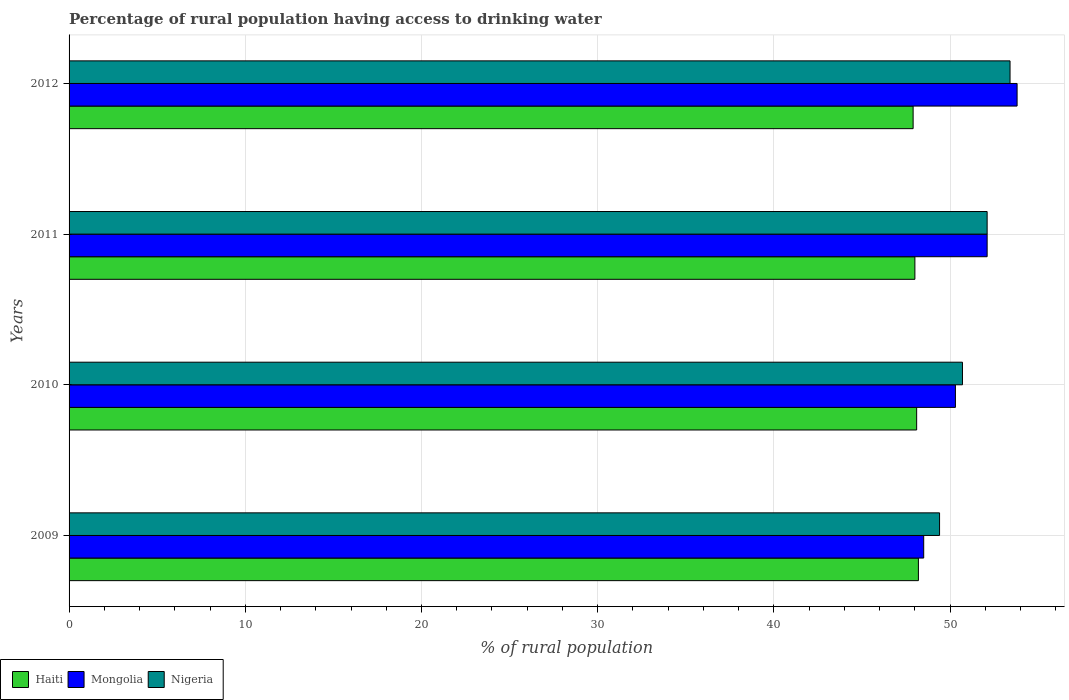Are the number of bars per tick equal to the number of legend labels?
Ensure brevity in your answer.  Yes. Are the number of bars on each tick of the Y-axis equal?
Your response must be concise. Yes. How many bars are there on the 1st tick from the top?
Make the answer very short. 3. What is the label of the 3rd group of bars from the top?
Offer a very short reply. 2010. What is the percentage of rural population having access to drinking water in Haiti in 2009?
Offer a terse response. 48.2. Across all years, what is the maximum percentage of rural population having access to drinking water in Mongolia?
Give a very brief answer. 53.8. Across all years, what is the minimum percentage of rural population having access to drinking water in Haiti?
Offer a very short reply. 47.9. What is the total percentage of rural population having access to drinking water in Haiti in the graph?
Your answer should be very brief. 192.2. What is the difference between the percentage of rural population having access to drinking water in Nigeria in 2010 and that in 2011?
Your answer should be very brief. -1.4. What is the difference between the percentage of rural population having access to drinking water in Nigeria in 2009 and the percentage of rural population having access to drinking water in Mongolia in 2011?
Give a very brief answer. -2.7. What is the average percentage of rural population having access to drinking water in Haiti per year?
Provide a succinct answer. 48.05. In the year 2011, what is the difference between the percentage of rural population having access to drinking water in Nigeria and percentage of rural population having access to drinking water in Haiti?
Your response must be concise. 4.1. In how many years, is the percentage of rural population having access to drinking water in Nigeria greater than 40 %?
Keep it short and to the point. 4. What is the ratio of the percentage of rural population having access to drinking water in Haiti in 2009 to that in 2011?
Offer a very short reply. 1. Is the percentage of rural population having access to drinking water in Mongolia in 2009 less than that in 2011?
Make the answer very short. Yes. Is the difference between the percentage of rural population having access to drinking water in Nigeria in 2010 and 2011 greater than the difference between the percentage of rural population having access to drinking water in Haiti in 2010 and 2011?
Offer a terse response. No. What is the difference between the highest and the second highest percentage of rural population having access to drinking water in Nigeria?
Keep it short and to the point. 1.3. What is the difference between the highest and the lowest percentage of rural population having access to drinking water in Haiti?
Your response must be concise. 0.3. What does the 3rd bar from the top in 2010 represents?
Give a very brief answer. Haiti. What does the 2nd bar from the bottom in 2009 represents?
Ensure brevity in your answer.  Mongolia. Is it the case that in every year, the sum of the percentage of rural population having access to drinking water in Haiti and percentage of rural population having access to drinking water in Mongolia is greater than the percentage of rural population having access to drinking water in Nigeria?
Provide a succinct answer. Yes. How many bars are there?
Provide a succinct answer. 12. Are the values on the major ticks of X-axis written in scientific E-notation?
Offer a terse response. No. Does the graph contain any zero values?
Offer a very short reply. No. Where does the legend appear in the graph?
Offer a terse response. Bottom left. What is the title of the graph?
Offer a terse response. Percentage of rural population having access to drinking water. What is the label or title of the X-axis?
Make the answer very short. % of rural population. What is the % of rural population of Haiti in 2009?
Make the answer very short. 48.2. What is the % of rural population of Mongolia in 2009?
Offer a very short reply. 48.5. What is the % of rural population in Nigeria in 2009?
Ensure brevity in your answer.  49.4. What is the % of rural population of Haiti in 2010?
Make the answer very short. 48.1. What is the % of rural population in Mongolia in 2010?
Ensure brevity in your answer.  50.3. What is the % of rural population of Nigeria in 2010?
Provide a short and direct response. 50.7. What is the % of rural population in Haiti in 2011?
Offer a terse response. 48. What is the % of rural population in Mongolia in 2011?
Your response must be concise. 52.1. What is the % of rural population in Nigeria in 2011?
Give a very brief answer. 52.1. What is the % of rural population of Haiti in 2012?
Keep it short and to the point. 47.9. What is the % of rural population of Mongolia in 2012?
Make the answer very short. 53.8. What is the % of rural population in Nigeria in 2012?
Provide a succinct answer. 53.4. Across all years, what is the maximum % of rural population in Haiti?
Your answer should be very brief. 48.2. Across all years, what is the maximum % of rural population in Mongolia?
Your response must be concise. 53.8. Across all years, what is the maximum % of rural population in Nigeria?
Your answer should be compact. 53.4. Across all years, what is the minimum % of rural population of Haiti?
Ensure brevity in your answer.  47.9. Across all years, what is the minimum % of rural population of Mongolia?
Your answer should be very brief. 48.5. Across all years, what is the minimum % of rural population of Nigeria?
Offer a terse response. 49.4. What is the total % of rural population of Haiti in the graph?
Offer a very short reply. 192.2. What is the total % of rural population of Mongolia in the graph?
Offer a terse response. 204.7. What is the total % of rural population of Nigeria in the graph?
Provide a succinct answer. 205.6. What is the difference between the % of rural population of Haiti in 2009 and that in 2011?
Keep it short and to the point. 0.2. What is the difference between the % of rural population of Mongolia in 2009 and that in 2011?
Keep it short and to the point. -3.6. What is the difference between the % of rural population in Haiti in 2009 and that in 2012?
Keep it short and to the point. 0.3. What is the difference between the % of rural population in Nigeria in 2009 and that in 2012?
Your response must be concise. -4. What is the difference between the % of rural population of Haiti in 2011 and that in 2012?
Your response must be concise. 0.1. What is the difference between the % of rural population in Mongolia in 2011 and that in 2012?
Give a very brief answer. -1.7. What is the difference between the % of rural population in Nigeria in 2011 and that in 2012?
Offer a terse response. -1.3. What is the difference between the % of rural population in Haiti in 2009 and the % of rural population in Mongolia in 2010?
Give a very brief answer. -2.1. What is the difference between the % of rural population of Haiti in 2009 and the % of rural population of Nigeria in 2010?
Offer a very short reply. -2.5. What is the difference between the % of rural population of Haiti in 2009 and the % of rural population of Mongolia in 2012?
Provide a succinct answer. -5.6. What is the difference between the % of rural population of Haiti in 2009 and the % of rural population of Nigeria in 2012?
Give a very brief answer. -5.2. What is the difference between the % of rural population in Haiti in 2010 and the % of rural population in Mongolia in 2011?
Ensure brevity in your answer.  -4. What is the difference between the % of rural population of Mongolia in 2010 and the % of rural population of Nigeria in 2011?
Offer a very short reply. -1.8. What is the difference between the % of rural population of Haiti in 2010 and the % of rural population of Nigeria in 2012?
Offer a terse response. -5.3. What is the difference between the % of rural population of Haiti in 2011 and the % of rural population of Nigeria in 2012?
Make the answer very short. -5.4. What is the average % of rural population of Haiti per year?
Give a very brief answer. 48.05. What is the average % of rural population in Mongolia per year?
Give a very brief answer. 51.17. What is the average % of rural population in Nigeria per year?
Ensure brevity in your answer.  51.4. In the year 2009, what is the difference between the % of rural population in Haiti and % of rural population in Mongolia?
Give a very brief answer. -0.3. In the year 2009, what is the difference between the % of rural population of Haiti and % of rural population of Nigeria?
Provide a short and direct response. -1.2. In the year 2009, what is the difference between the % of rural population in Mongolia and % of rural population in Nigeria?
Your response must be concise. -0.9. In the year 2010, what is the difference between the % of rural population in Haiti and % of rural population in Mongolia?
Give a very brief answer. -2.2. In the year 2010, what is the difference between the % of rural population in Haiti and % of rural population in Nigeria?
Give a very brief answer. -2.6. In the year 2010, what is the difference between the % of rural population of Mongolia and % of rural population of Nigeria?
Make the answer very short. -0.4. In the year 2012, what is the difference between the % of rural population in Haiti and % of rural population in Nigeria?
Provide a short and direct response. -5.5. In the year 2012, what is the difference between the % of rural population of Mongolia and % of rural population of Nigeria?
Offer a terse response. 0.4. What is the ratio of the % of rural population in Mongolia in 2009 to that in 2010?
Provide a short and direct response. 0.96. What is the ratio of the % of rural population of Nigeria in 2009 to that in 2010?
Your answer should be very brief. 0.97. What is the ratio of the % of rural population in Mongolia in 2009 to that in 2011?
Offer a very short reply. 0.93. What is the ratio of the % of rural population of Nigeria in 2009 to that in 2011?
Make the answer very short. 0.95. What is the ratio of the % of rural population in Mongolia in 2009 to that in 2012?
Offer a terse response. 0.9. What is the ratio of the % of rural population of Nigeria in 2009 to that in 2012?
Your response must be concise. 0.93. What is the ratio of the % of rural population in Mongolia in 2010 to that in 2011?
Your answer should be very brief. 0.97. What is the ratio of the % of rural population of Nigeria in 2010 to that in 2011?
Your answer should be very brief. 0.97. What is the ratio of the % of rural population of Haiti in 2010 to that in 2012?
Your answer should be very brief. 1. What is the ratio of the % of rural population of Mongolia in 2010 to that in 2012?
Ensure brevity in your answer.  0.93. What is the ratio of the % of rural population of Nigeria in 2010 to that in 2012?
Provide a short and direct response. 0.95. What is the ratio of the % of rural population of Mongolia in 2011 to that in 2012?
Make the answer very short. 0.97. What is the ratio of the % of rural population of Nigeria in 2011 to that in 2012?
Provide a short and direct response. 0.98. What is the difference between the highest and the second highest % of rural population in Haiti?
Provide a short and direct response. 0.1. What is the difference between the highest and the second highest % of rural population in Mongolia?
Your answer should be very brief. 1.7. What is the difference between the highest and the second highest % of rural population of Nigeria?
Offer a very short reply. 1.3. What is the difference between the highest and the lowest % of rural population of Haiti?
Keep it short and to the point. 0.3. What is the difference between the highest and the lowest % of rural population of Mongolia?
Ensure brevity in your answer.  5.3. 